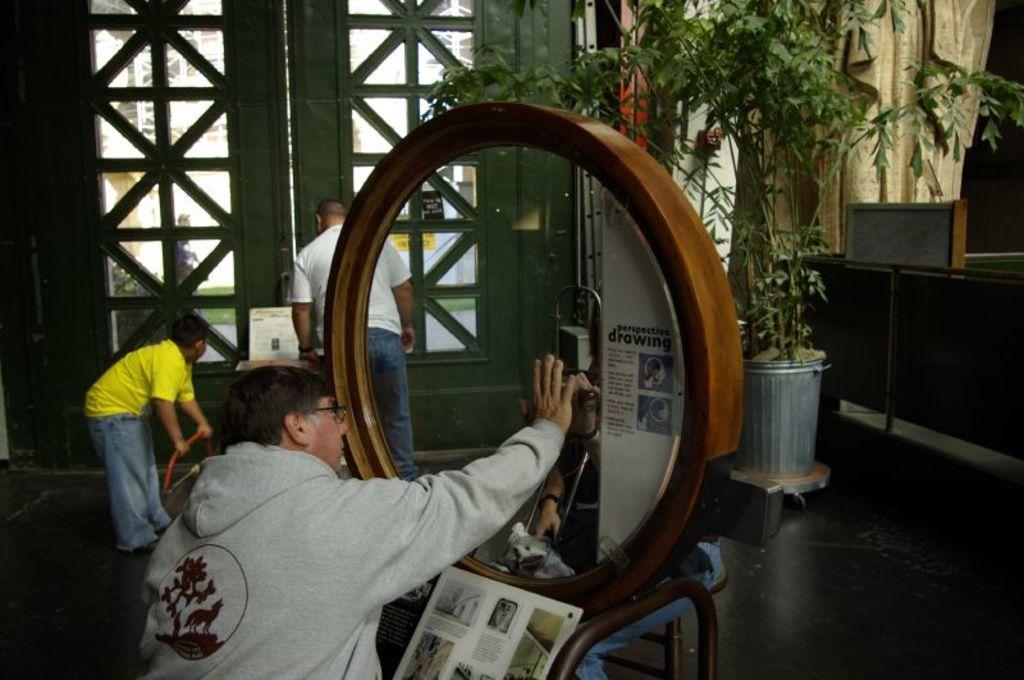In one or two sentences, can you explain what this image depicts? Here a man is placing his hand on the glass, he wore sweater. On the right side there is a plant, on the left side there is a door. A man is observing it. 